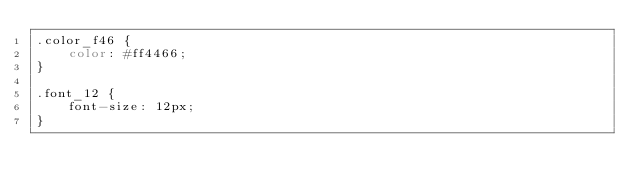<code> <loc_0><loc_0><loc_500><loc_500><_CSS_>.color_f46 {
    color: #ff4466;
}

.font_12 {
    font-size: 12px;
}</code> 